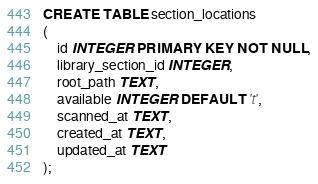<code> <loc_0><loc_0><loc_500><loc_500><_SQL_>CREATE TABLE section_locations
(
    id INTEGER PRIMARY KEY NOT NULL,
    library_section_id INTEGER,
    root_path TEXT,
    available INTEGER DEFAULT 't',
    scanned_at TEXT,
    created_at TEXT,
    updated_at TEXT
);
</code> 